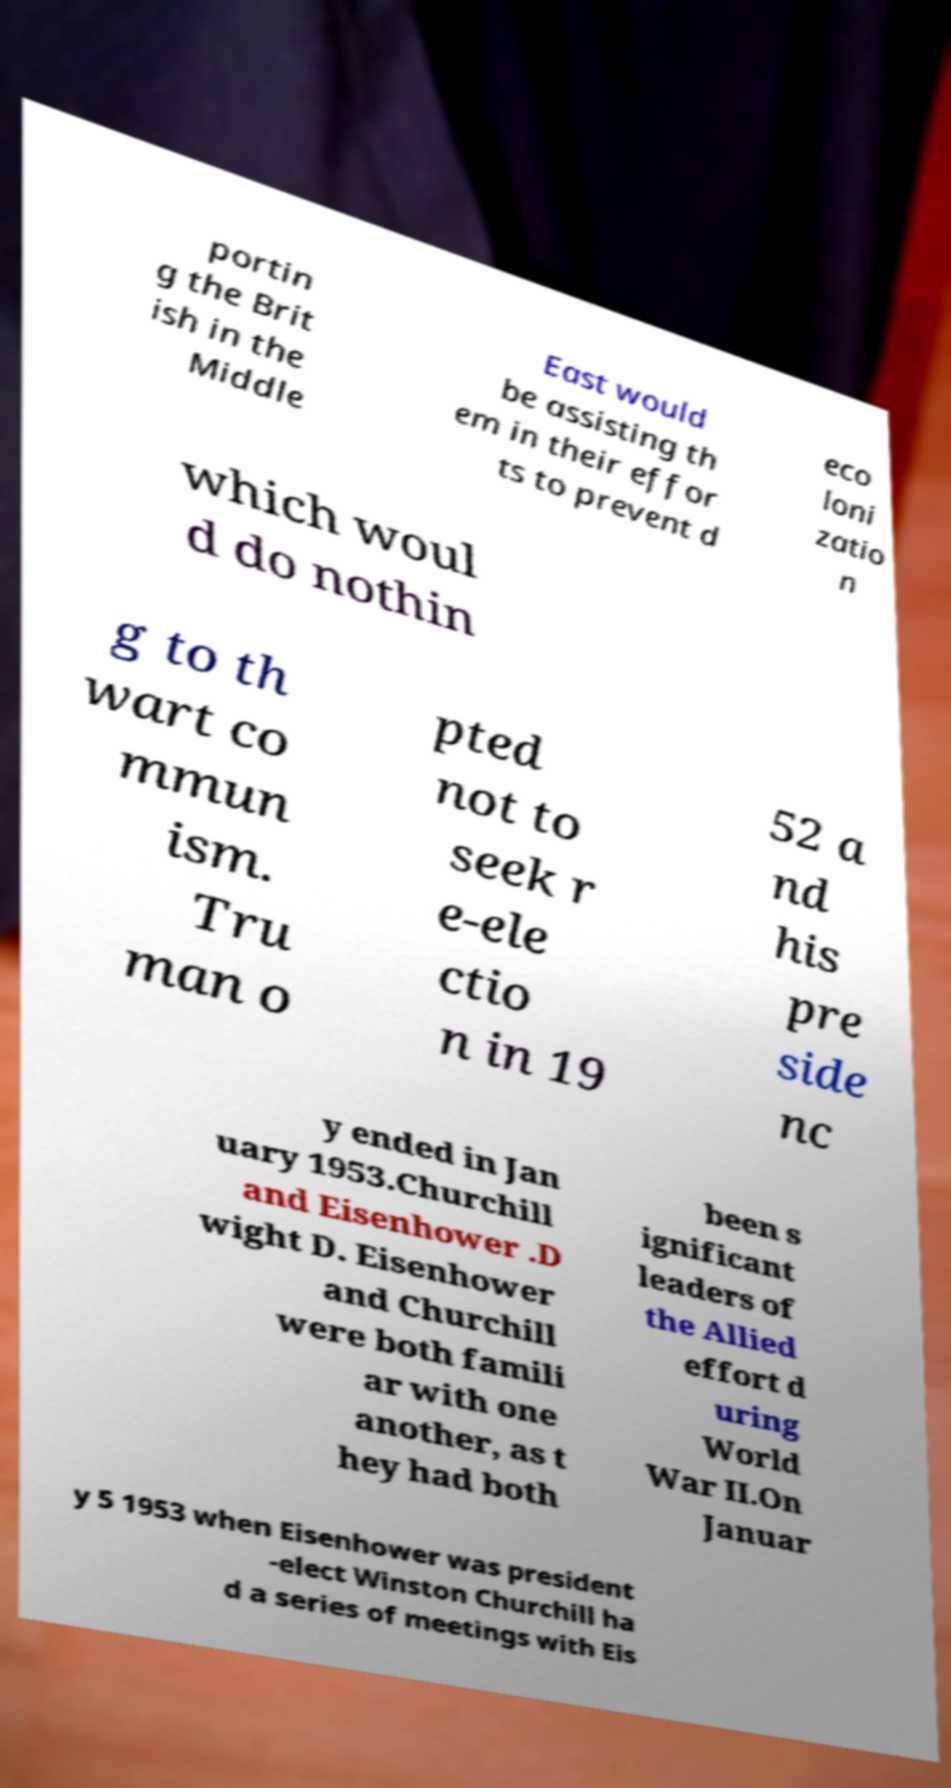Could you assist in decoding the text presented in this image and type it out clearly? portin g the Brit ish in the Middle East would be assisting th em in their effor ts to prevent d eco loni zatio n which woul d do nothin g to th wart co mmun ism. Tru man o pted not to seek r e-ele ctio n in 19 52 a nd his pre side nc y ended in Jan uary 1953.Churchill and Eisenhower .D wight D. Eisenhower and Churchill were both famili ar with one another, as t hey had both been s ignificant leaders of the Allied effort d uring World War II.On Januar y 5 1953 when Eisenhower was president -elect Winston Churchill ha d a series of meetings with Eis 